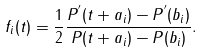<formula> <loc_0><loc_0><loc_500><loc_500>f _ { i } ( t ) = \frac { 1 } { 2 } \frac { P ^ { ^ { \prime } } ( t + a _ { i } ) - P ^ { ^ { \prime } } ( b _ { i } ) } { P ( t + a _ { i } ) - P ( b _ { i } ) } .</formula> 